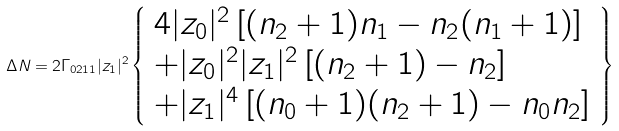<formula> <loc_0><loc_0><loc_500><loc_500>\Delta N = 2 \Gamma _ { 0 2 1 1 } | z _ { 1 } | ^ { 2 } \left \{ \begin{array} { l } 4 | z _ { 0 } | ^ { 2 } \left [ ( n _ { 2 } + 1 ) n _ { 1 } - n _ { 2 } ( n _ { 1 } + 1 ) \right ] \\ + | z _ { 0 } | ^ { 2 } | z _ { 1 } | ^ { 2 } \left [ ( n _ { 2 } + 1 ) - n _ { 2 } \right ] \\ + | z _ { 1 } | ^ { 4 } \left [ ( n _ { 0 } + 1 ) ( n _ { 2 } + 1 ) - n _ { 0 } n _ { 2 } \right ] \end{array} \right \}</formula> 